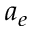<formula> <loc_0><loc_0><loc_500><loc_500>a _ { e }</formula> 